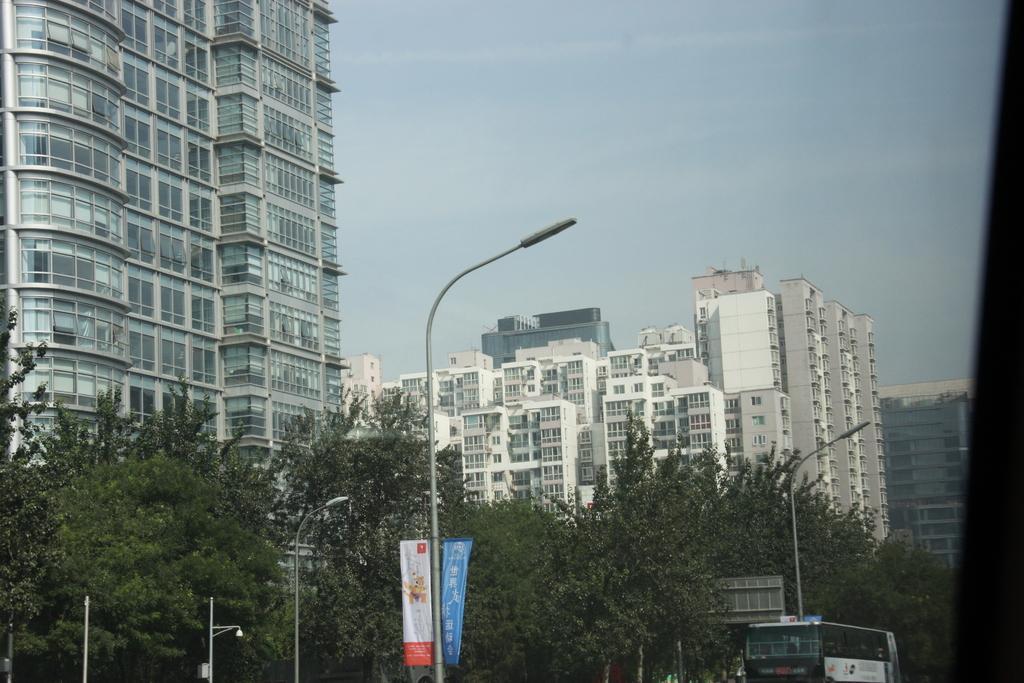Please provide a concise description of this image. There are trees, poles and a bus in the foreground area of the image, there are buildings and the sky in the background. 